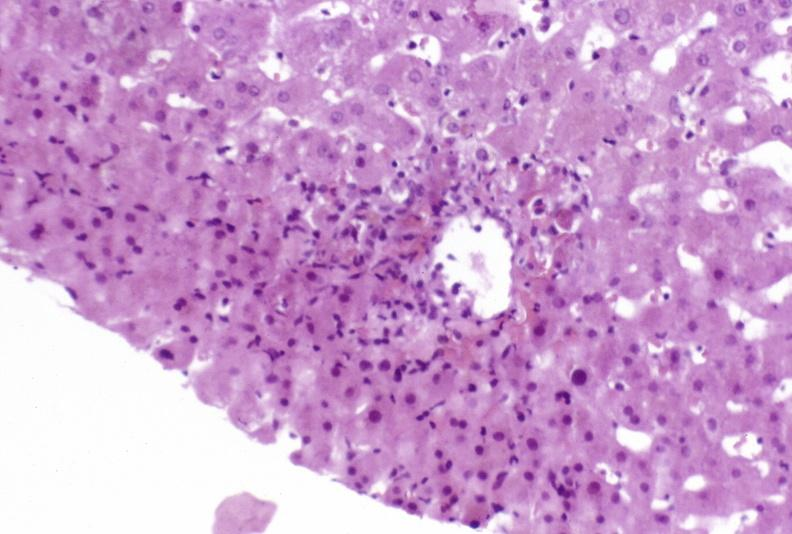s stein leventhal present?
Answer the question using a single word or phrase. No 